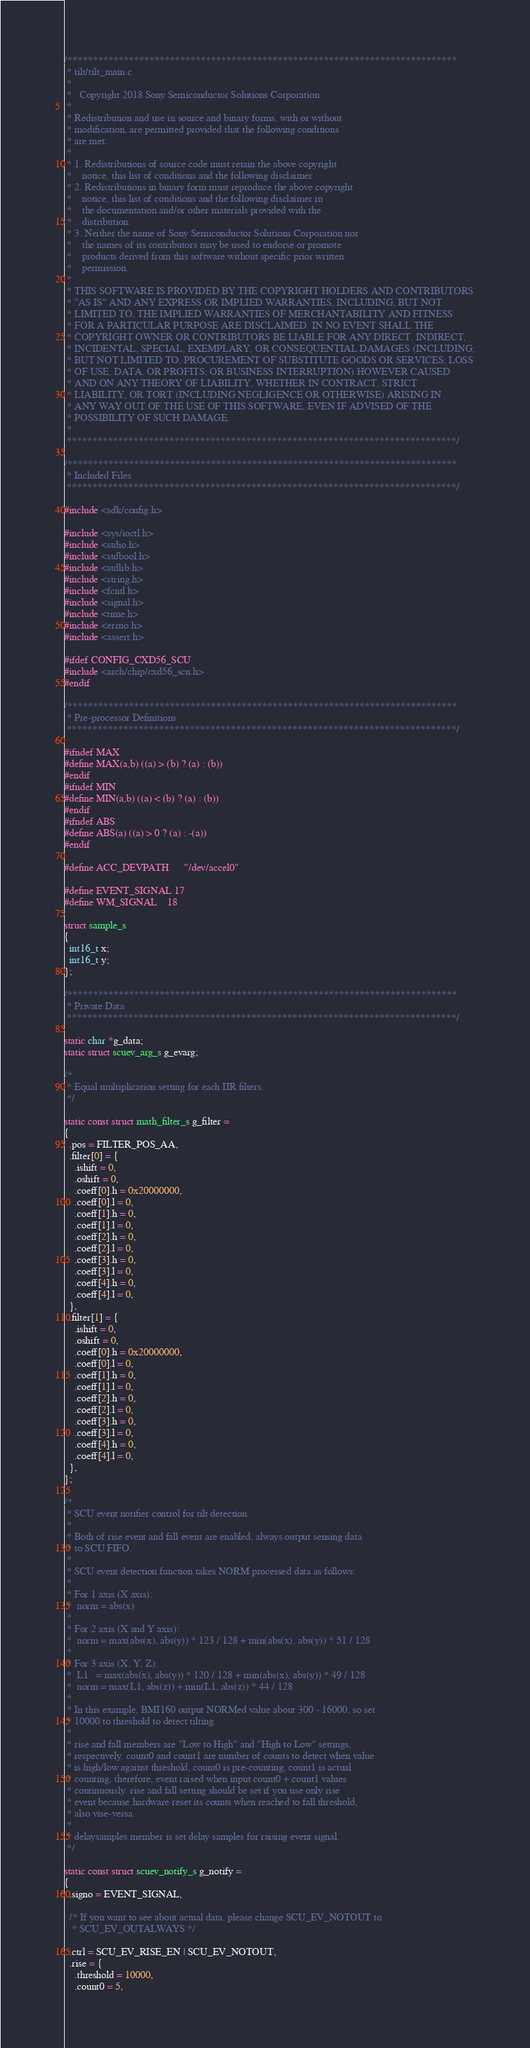<code> <loc_0><loc_0><loc_500><loc_500><_C_>/****************************************************************************
 * tilt/tilt_main.c
 *
 *   Copyright 2018 Sony Semiconductor Solutions Corporation
 *
 * Redistribution and use in source and binary forms, with or without
 * modification, are permitted provided that the following conditions
 * are met:
 *
 * 1. Redistributions of source code must retain the above copyright
 *    notice, this list of conditions and the following disclaimer.
 * 2. Redistributions in binary form must reproduce the above copyright
 *    notice, this list of conditions and the following disclaimer in
 *    the documentation and/or other materials provided with the
 *    distribution.
 * 3. Neither the name of Sony Semiconductor Solutions Corporation nor
 *    the names of its contributors may be used to endorse or promote
 *    products derived from this software without specific prior written
 *    permission.
 *
 * THIS SOFTWARE IS PROVIDED BY THE COPYRIGHT HOLDERS AND CONTRIBUTORS
 * "AS IS" AND ANY EXPRESS OR IMPLIED WARRANTIES, INCLUDING, BUT NOT
 * LIMITED TO, THE IMPLIED WARRANTIES OF MERCHANTABILITY AND FITNESS
 * FOR A PARTICULAR PURPOSE ARE DISCLAIMED. IN NO EVENT SHALL THE
 * COPYRIGHT OWNER OR CONTRIBUTORS BE LIABLE FOR ANY DIRECT, INDIRECT,
 * INCIDENTAL, SPECIAL, EXEMPLARY, OR CONSEQUENTIAL DAMAGES (INCLUDING,
 * BUT NOT LIMITED TO, PROCUREMENT OF SUBSTITUTE GOODS OR SERVICES; LOSS
 * OF USE, DATA, OR PROFITS; OR BUSINESS INTERRUPTION) HOWEVER CAUSED
 * AND ON ANY THEORY OF LIABILITY, WHETHER IN CONTRACT, STRICT
 * LIABILITY, OR TORT (INCLUDING NEGLIGENCE OR OTHERWISE) ARISING IN
 * ANY WAY OUT OF THE USE OF THIS SOFTWARE, EVEN IF ADVISED OF THE
 * POSSIBILITY OF SUCH DAMAGE.
 *
 ****************************************************************************/

/****************************************************************************
 * Included Files
 ****************************************************************************/

#include <sdk/config.h>

#include <sys/ioctl.h>
#include <stdio.h>
#include <stdbool.h>
#include <stdlib.h>
#include <string.h>
#include <fcntl.h>
#include <signal.h>
#include <time.h>
#include <errno.h>
#include <assert.h>

#ifdef CONFIG_CXD56_SCU
#include <arch/chip/cxd56_scu.h>
#endif

/****************************************************************************
 * Pre-processor Definitions
 ****************************************************************************/

#ifndef MAX
#define MAX(a,b) ((a) > (b) ? (a) : (b))
#endif
#ifndef MIN
#define MIN(a,b) ((a) < (b) ? (a) : (b))
#endif
#ifndef ABS
#define ABS(a) ((a) > 0 ? (a) : -(a))
#endif

#define ACC_DEVPATH      "/dev/accel0"

#define EVENT_SIGNAL 17
#define WM_SIGNAL    18

struct sample_s
{
  int16_t x;
  int16_t y;
};

/****************************************************************************
 * Private Data
 ****************************************************************************/

static char *g_data;
static struct scuev_arg_s g_evarg;

/*
 * Equal multiplication setting for each IIR filters.
 */

static const struct math_filter_s g_filter =
{
  .pos = FILTER_POS_AA,
  .filter[0] = {
    .ishift = 0,
    .oshift = 0,
    .coeff[0].h = 0x20000000,
    .coeff[0].l = 0,
    .coeff[1].h = 0,
    .coeff[1].l = 0,
    .coeff[2].h = 0,
    .coeff[2].l = 0,
    .coeff[3].h = 0,
    .coeff[3].l = 0,
    .coeff[4].h = 0,
    .coeff[4].l = 0,
  },
  .filter[1] = {
    .ishift = 0,
    .oshift = 0,
    .coeff[0].h = 0x20000000,
    .coeff[0].l = 0,
    .coeff[1].h = 0,
    .coeff[1].l = 0,
    .coeff[2].h = 0,
    .coeff[2].l = 0,
    .coeff[3].h = 0,
    .coeff[3].l = 0,
    .coeff[4].h = 0,
    .coeff[4].l = 0,
  },
};

/*
 * SCU event notifier control for tilt detection
 *
 * Both of rise event and fall event are enabled, always output sensing data
 * to SCU FIFO.
 *
 * SCU event detection function takes NORM processed data as follows:
 *
 * For 1 axis (X axis):
 *  norm = abs(x)
 *
 * For 2 axis (X and Y axis):
 *  norm = max(abs(x), abs(y)) * 123 / 128 + min(abs(x), abs(y)) * 51 / 128
 *
 * For 3 axis (X, Y, Z):
 *  L1   = max(abs(x), abs(y)) * 120 / 128 + min(abs(x), abs(y)) * 49 / 128
 *  norm = max(L1, abs(z)) + min(L1, abs(z)) * 44 / 128
 *
 * In this example, BMI160 output NORMed value about 300 - 16000, so set
 * 10000 to threshold to detect tilting.
 *
 * rise and fall members are "Low to High" and "High to Low" settings,
 * respectively. count0 and count1 are number of counts to detect when value
 * is high/low against threshold, count0 is pre-counting, count1 is actual
 * counting, therefore, event raised when input count0 + count1 values
 * continuously. rise and fall setting should be set if you use only rise
 * event because hardware reset its counts when reached to fall.threshold,
 * also vise-versa.
 *
 * delaysamples member is set delay samples for raising event signal.
 */

static const struct scuev_notify_s g_notify =
{
  .signo = EVENT_SIGNAL,

  /* If you want to see about actual data, please change SCU_EV_NOTOUT to
   * SCU_EV_OUTALWAYS */

  .ctrl = SCU_EV_RISE_EN | SCU_EV_NOTOUT,
  .rise = {
    .threshold = 10000,
    .count0 = 5,</code> 